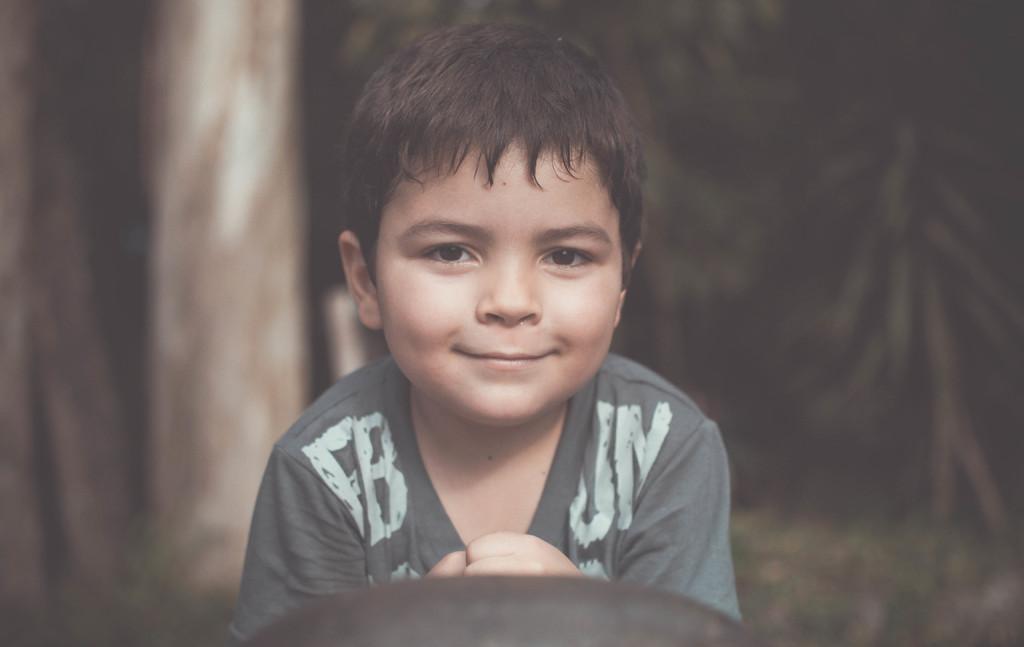Describe this image in one or two sentences. In front of the picture, we see a boy in grey T-shirt is smiling. Behind him, it is in black and brown color. It is blurred in the background. 